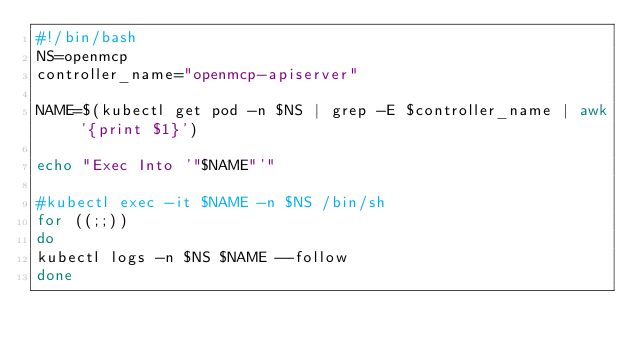<code> <loc_0><loc_0><loc_500><loc_500><_Bash_>#!/bin/bash
NS=openmcp
controller_name="openmcp-apiserver"

NAME=$(kubectl get pod -n $NS | grep -E $controller_name | awk '{print $1}')

echo "Exec Into '"$NAME"'"

#kubectl exec -it $NAME -n $NS /bin/sh
for ((;;))
do
kubectl logs -n $NS $NAME --follow
done

</code> 